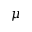<formula> <loc_0><loc_0><loc_500><loc_500>\mu</formula> 